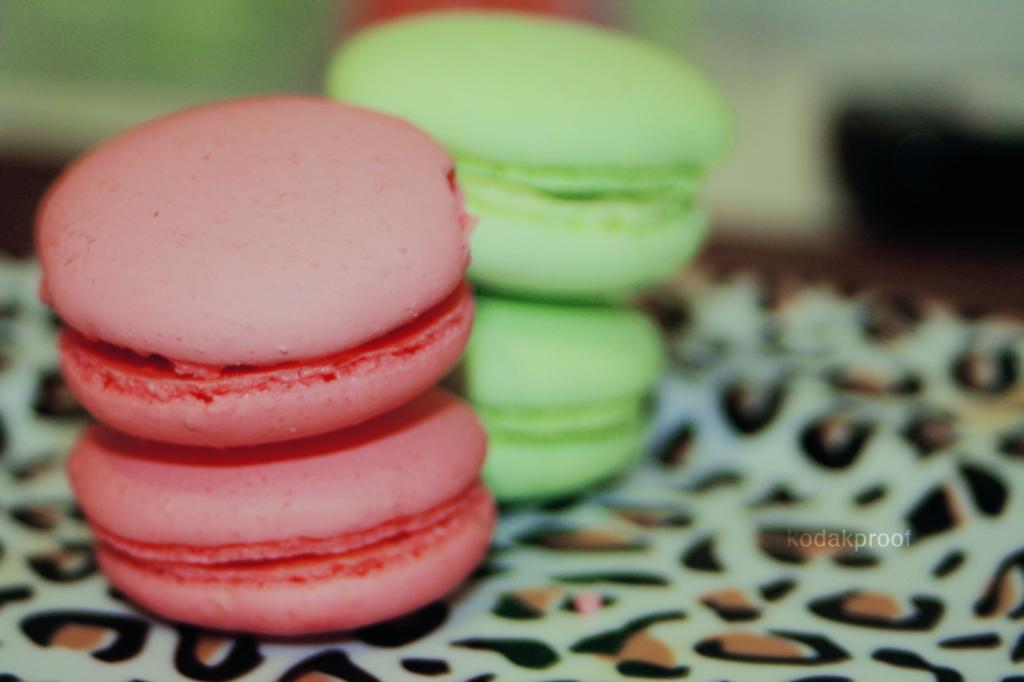What is present on the plate in the image? The plate contains food items. What can be observed about the colors of the food items on the plate? The food items have red and green colors. What is the distance between the plate and the love in the image? There is no mention of love in the image, so it is not possible to determine the distance between the plate and love. 